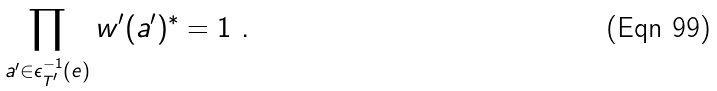Convert formula to latex. <formula><loc_0><loc_0><loc_500><loc_500>\prod _ { a ^ { \prime } \in \epsilon _ { T ^ { \prime } } ^ { - 1 } ( e ) } w ^ { \prime } ( a ^ { \prime } ) ^ { * } = 1 \ .</formula> 